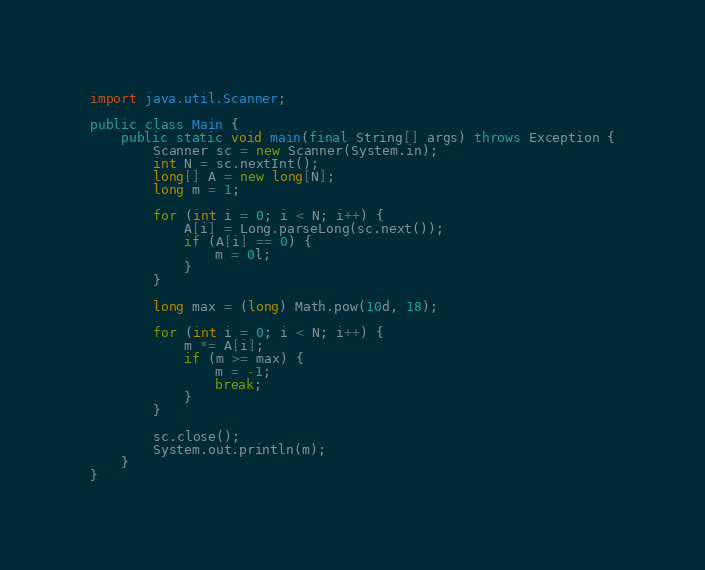<code> <loc_0><loc_0><loc_500><loc_500><_Java_>import java.util.Scanner;

public class Main {
    public static void main(final String[] args) throws Exception {
        Scanner sc = new Scanner(System.in);
        int N = sc.nextInt();
        long[] A = new long[N];
        long m = 1;

        for (int i = 0; i < N; i++) {
            A[i] = Long.parseLong(sc.next());
            if (A[i] == 0) {
                m = 0l;
            }
        }

        long max = (long) Math.pow(10d, 18);

        for (int i = 0; i < N; i++) {
            m *= A[i];
            if (m >= max) {
                m = -1;
                break;
            }
        }

        sc.close();
        System.out.println(m);
    }
}
</code> 